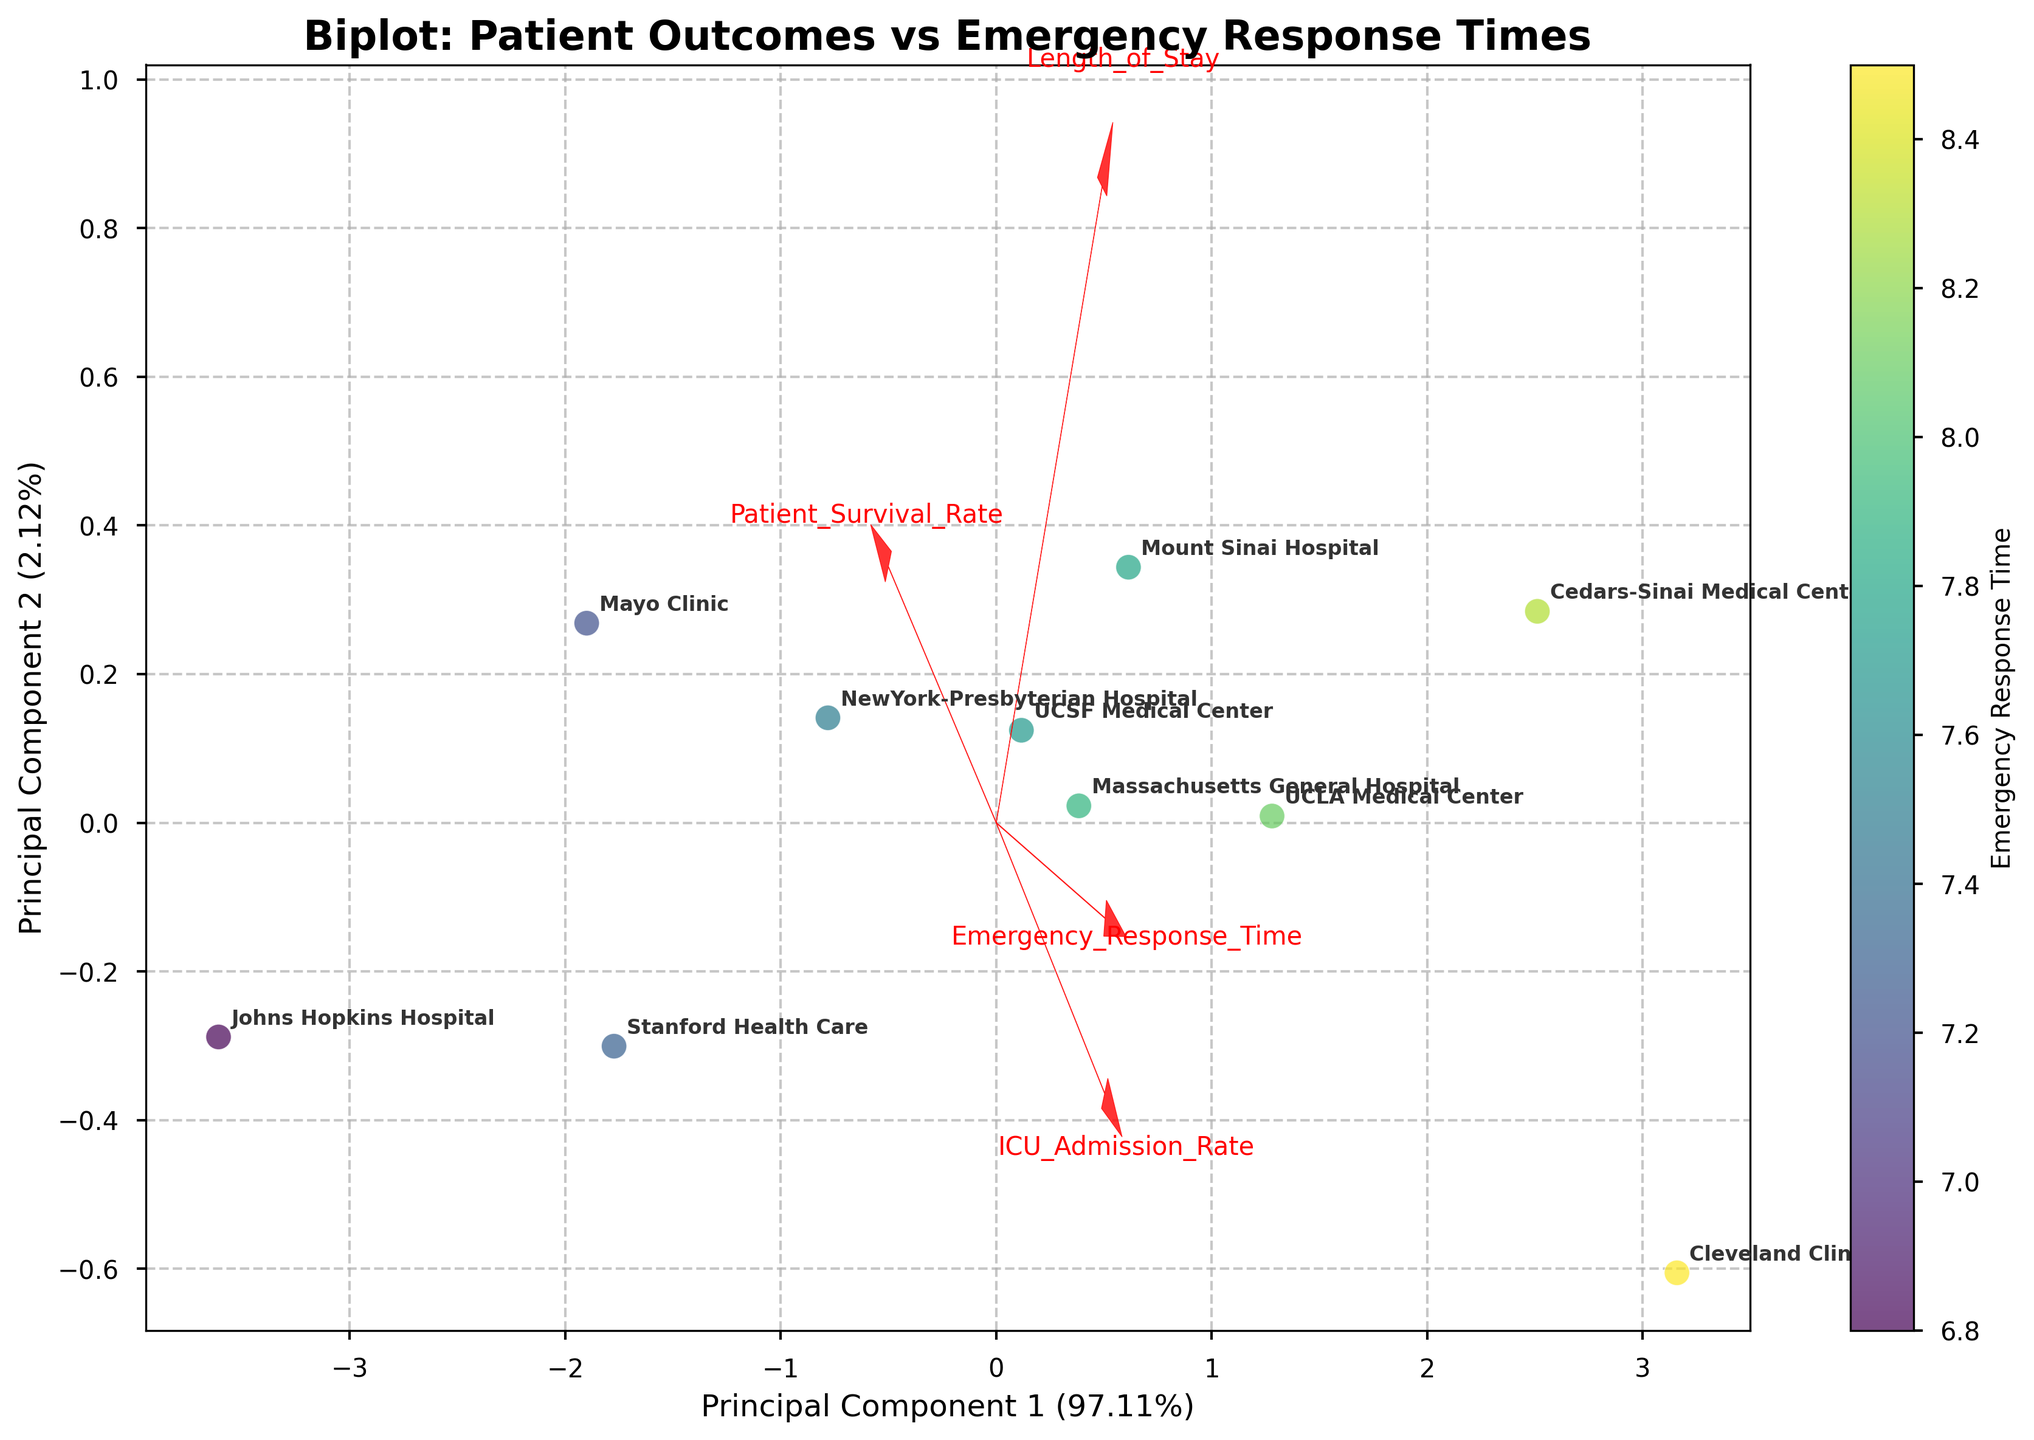What is the title of the biplot? The title is typically located at the top of the figure in bold text. In this case, the text reads "Biplot: Patient Outcomes vs Emergency Response Times".
Answer: Biplot: Patient Outcomes vs Emergency Response Times How many healthcare facilities are represented in the plot? There are labels on the points in the scatter plot, each representing a different healthcare facility. By counting these labels, we determine the number of facilities. In this case, there are 10 healthcare facilities.
Answer: 10 Which hospital has the shortest emergency response time? The scatter plot has data points colored based on emergency response times, with a color bar on the right showing this scaling. By looking at the color and verifying with labeled points, we identify the hospital with the shortest response time. Johns Hopkins Hospital, with an Emergency Response Time of 6.8 minutes, has the shortest time.
Answer: Johns Hopkins Hospital What are the principal components' axes labeled as? The labels for the principal components' axes can be found along the x-axis and y-axis. The axes are labeled respectively as "Principal Component 1 (percentage)" and "Principal Component 2 (percentage)". These labels show the explained variance ratio for each principal component.
Answer: Principal Component 1 and Principal Component 2 Which feature has the highest loading on Principal Component 1? The biplot shows feature vectors as red arrows pointing in different directions from the origin. The components with the highest loading on Principal Component 1 will have the longest arrow in the direction of that axis. "Patient Survival Rate" has the arrow pointing furthest in the x-direction, indicating the highest loading for PC1.
Answer: Patient Survival Rate Does the plot indicate any correlation between Length of Stay and Emergency Response Time? The arrows for feature vectors on the plot show correlations. Positively correlated features point in the same direction, and negatively correlated features point in opposite directions. The arrows for "Emergency Response Time" and "Length of Stay" point in similar directions, indicating a positive correlation.
Answer: Positive correlation Which hospital is represented closest to the origin of the biplot? The origin of the biplot (0,0) represents the center of the chart. The hospital closest to this point in both the first and second principal component dimensions is UCSF Medical Center.
Answer: UCSF Medical Center Are the ICU Admission Rate and Length of Stay positively or negatively correlated according to the plot? On the biplot, the arrows for feature vectors indicate the direction and magnitude of each feature's contribution to the principal components. The "ICU Admission Rate" and "Length of Stay" arrows are pointing in similar directions, indicating they are positively correlated.
Answer: Positively correlated Which hospital has a higher Patient Survival Rate, Mayo Clinic or Cleveland Clinic? By locating the two points labeled "Mayo Clinic" and "Cleveland Clinic" on the scatter plot and considering their relative positions in terms of the Patient Survival Rate loading direction, we can see that Mayo Clinic has a higher Patient Survival Rate.
Answer: Mayo Clinic 